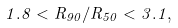Convert formula to latex. <formula><loc_0><loc_0><loc_500><loc_500>1 . 8 < R _ { 9 0 } / R _ { 5 0 } < 3 . 1 ,</formula> 